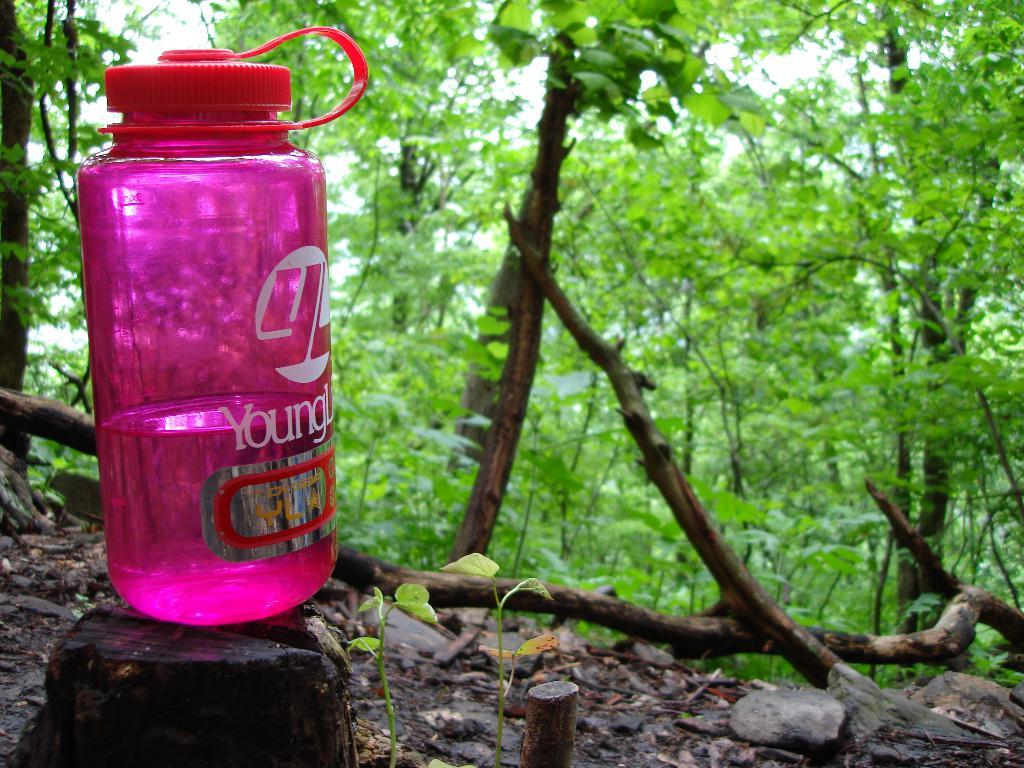What color is the water bottle in the image? The water bottle in the image is pink. Where is the water bottle located in the image? The water bottle is on the left side of the image. What can be seen in the background of the image? There are trees in the background of the image. What type of animal can be seen playing in the garden in the image? There is no garden or animal present in the image; it only features a pink water bottle on the left side and trees in the background. 